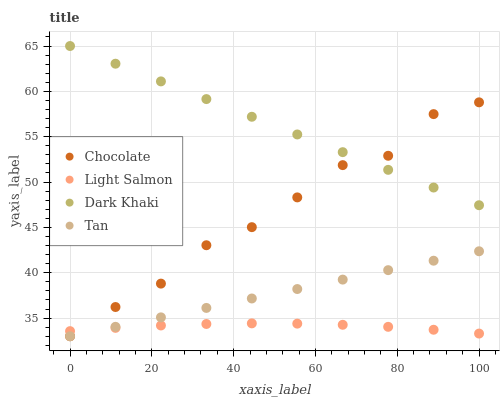Does Light Salmon have the minimum area under the curve?
Answer yes or no. Yes. Does Dark Khaki have the maximum area under the curve?
Answer yes or no. Yes. Does Tan have the minimum area under the curve?
Answer yes or no. No. Does Tan have the maximum area under the curve?
Answer yes or no. No. Is Tan the smoothest?
Answer yes or no. Yes. Is Chocolate the roughest?
Answer yes or no. Yes. Is Light Salmon the smoothest?
Answer yes or no. No. Is Light Salmon the roughest?
Answer yes or no. No. Does Tan have the lowest value?
Answer yes or no. Yes. Does Light Salmon have the lowest value?
Answer yes or no. No. Does Dark Khaki have the highest value?
Answer yes or no. Yes. Does Tan have the highest value?
Answer yes or no. No. Is Tan less than Dark Khaki?
Answer yes or no. Yes. Is Dark Khaki greater than Tan?
Answer yes or no. Yes. Does Chocolate intersect Dark Khaki?
Answer yes or no. Yes. Is Chocolate less than Dark Khaki?
Answer yes or no. No. Is Chocolate greater than Dark Khaki?
Answer yes or no. No. Does Tan intersect Dark Khaki?
Answer yes or no. No. 